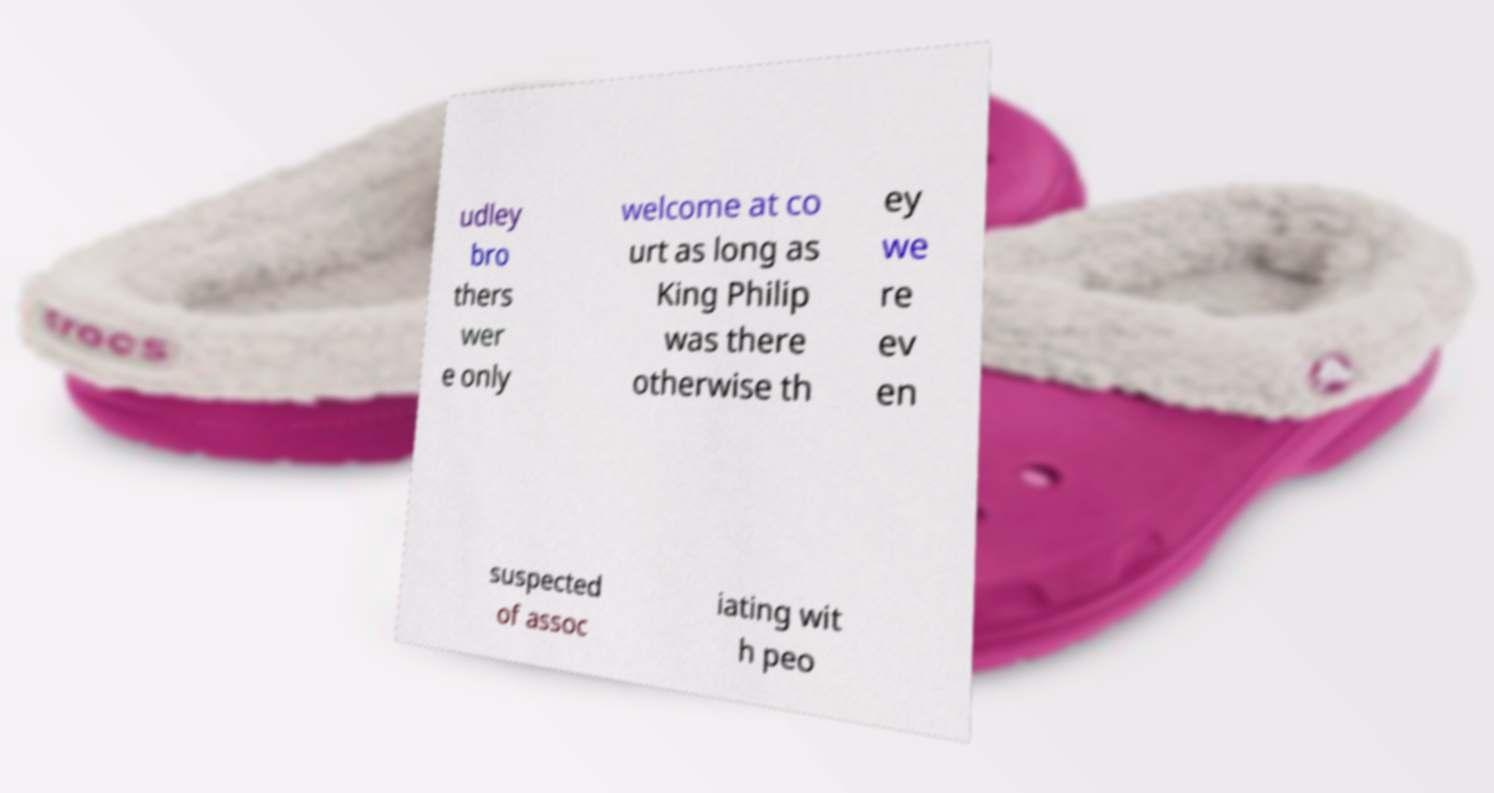Can you read and provide the text displayed in the image?This photo seems to have some interesting text. Can you extract and type it out for me? udley bro thers wer e only welcome at co urt as long as King Philip was there otherwise th ey we re ev en suspected of assoc iating wit h peo 